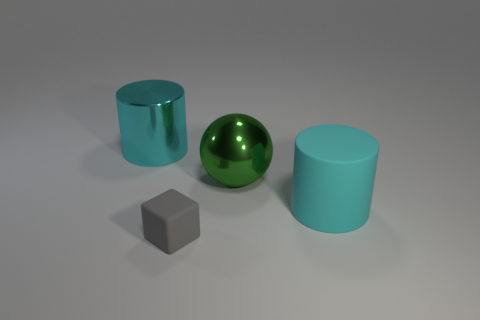In terms of size, how do the cylinders compare to the sphere? The cylinders are both taller than the green metallic sphere, but their diameters are smaller compared to the sphere's circumference. The height difference accentuates the contrasting shapes and sizes among the objects in the image. Does the light source affect the appearance of these objects differently? Yes, the light source is creating a soft reflection on the metallic surfaces of the green sphere and the left cylinder, highlighting their glossy texture. On the other hand, the matte rubber-like surface of the right cylinder diffuses the light, resulting in a less pronounced reflection and giving the object a flatter appearance. 